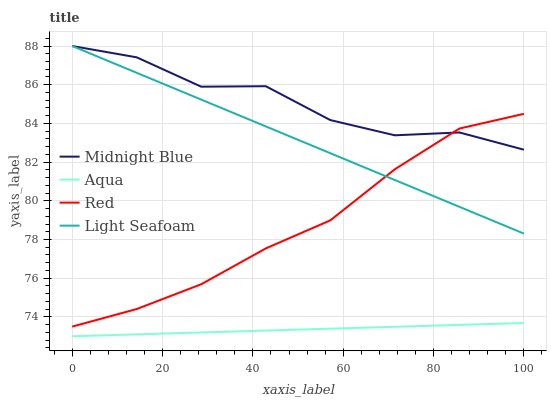Does Aqua have the minimum area under the curve?
Answer yes or no. Yes. Does Midnight Blue have the maximum area under the curve?
Answer yes or no. Yes. Does Midnight Blue have the minimum area under the curve?
Answer yes or no. No. Does Aqua have the maximum area under the curve?
Answer yes or no. No. Is Light Seafoam the smoothest?
Answer yes or no. Yes. Is Midnight Blue the roughest?
Answer yes or no. Yes. Is Aqua the smoothest?
Answer yes or no. No. Is Aqua the roughest?
Answer yes or no. No. Does Aqua have the lowest value?
Answer yes or no. Yes. Does Midnight Blue have the lowest value?
Answer yes or no. No. Does Midnight Blue have the highest value?
Answer yes or no. Yes. Does Aqua have the highest value?
Answer yes or no. No. Is Aqua less than Light Seafoam?
Answer yes or no. Yes. Is Red greater than Aqua?
Answer yes or no. Yes. Does Light Seafoam intersect Midnight Blue?
Answer yes or no. Yes. Is Light Seafoam less than Midnight Blue?
Answer yes or no. No. Is Light Seafoam greater than Midnight Blue?
Answer yes or no. No. Does Aqua intersect Light Seafoam?
Answer yes or no. No. 